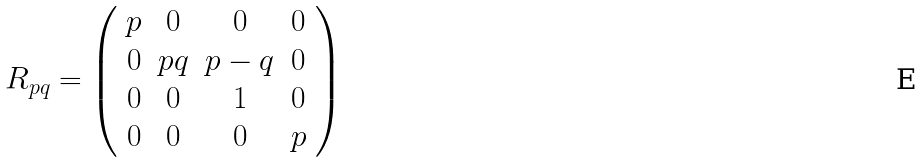<formula> <loc_0><loc_0><loc_500><loc_500>R _ { p q } = \left ( \begin{array} { c c c c } p & 0 & 0 & 0 \\ 0 & p q & p - q & 0 \\ 0 & 0 & 1 & 0 \\ 0 & 0 & 0 & p \end{array} \right )</formula> 